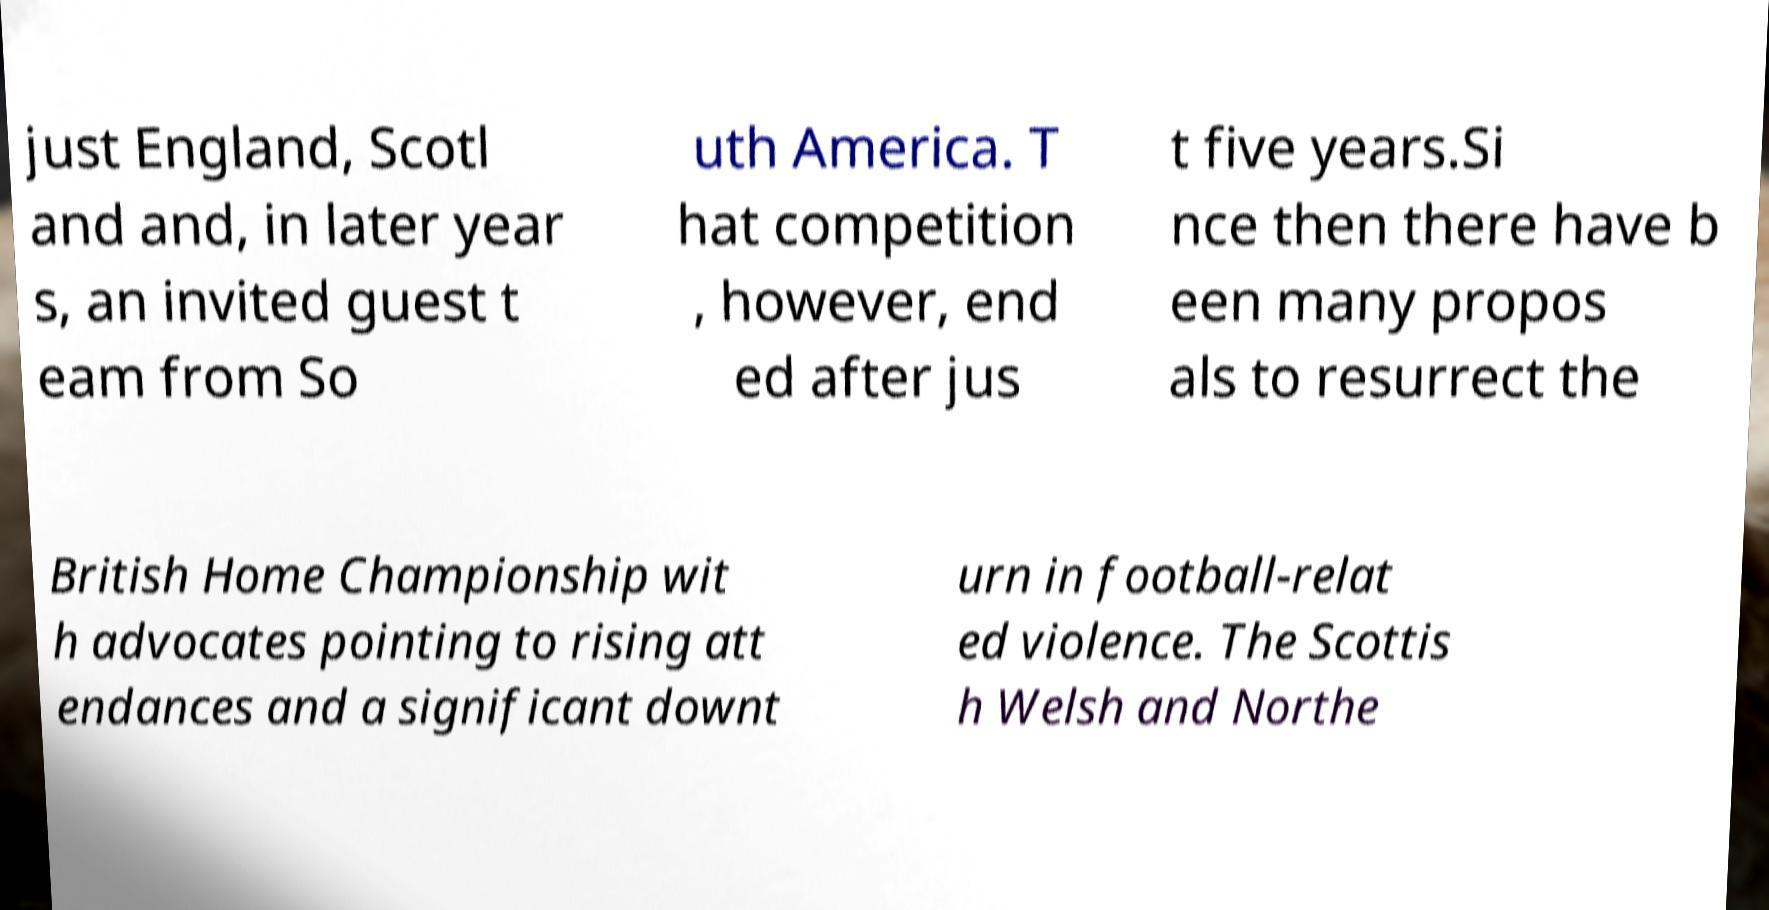I need the written content from this picture converted into text. Can you do that? just England, Scotl and and, in later year s, an invited guest t eam from So uth America. T hat competition , however, end ed after jus t five years.Si nce then there have b een many propos als to resurrect the British Home Championship wit h advocates pointing to rising att endances and a significant downt urn in football-relat ed violence. The Scottis h Welsh and Northe 